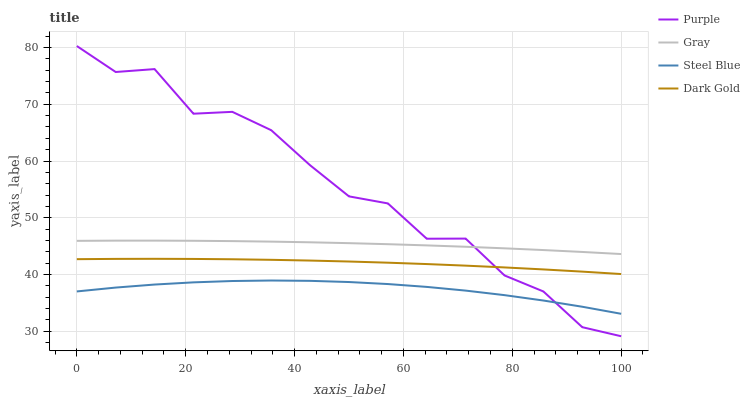Does Steel Blue have the minimum area under the curve?
Answer yes or no. Yes. Does Purple have the maximum area under the curve?
Answer yes or no. Yes. Does Gray have the minimum area under the curve?
Answer yes or no. No. Does Gray have the maximum area under the curve?
Answer yes or no. No. Is Gray the smoothest?
Answer yes or no. Yes. Is Purple the roughest?
Answer yes or no. Yes. Is Steel Blue the smoothest?
Answer yes or no. No. Is Steel Blue the roughest?
Answer yes or no. No. Does Purple have the lowest value?
Answer yes or no. Yes. Does Steel Blue have the lowest value?
Answer yes or no. No. Does Purple have the highest value?
Answer yes or no. Yes. Does Gray have the highest value?
Answer yes or no. No. Is Steel Blue less than Gray?
Answer yes or no. Yes. Is Gray greater than Steel Blue?
Answer yes or no. Yes. Does Purple intersect Gray?
Answer yes or no. Yes. Is Purple less than Gray?
Answer yes or no. No. Is Purple greater than Gray?
Answer yes or no. No. Does Steel Blue intersect Gray?
Answer yes or no. No. 